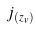Convert formula to latex. <formula><loc_0><loc_0><loc_500><loc_500>j _ { ( z _ { v } ) }</formula> 